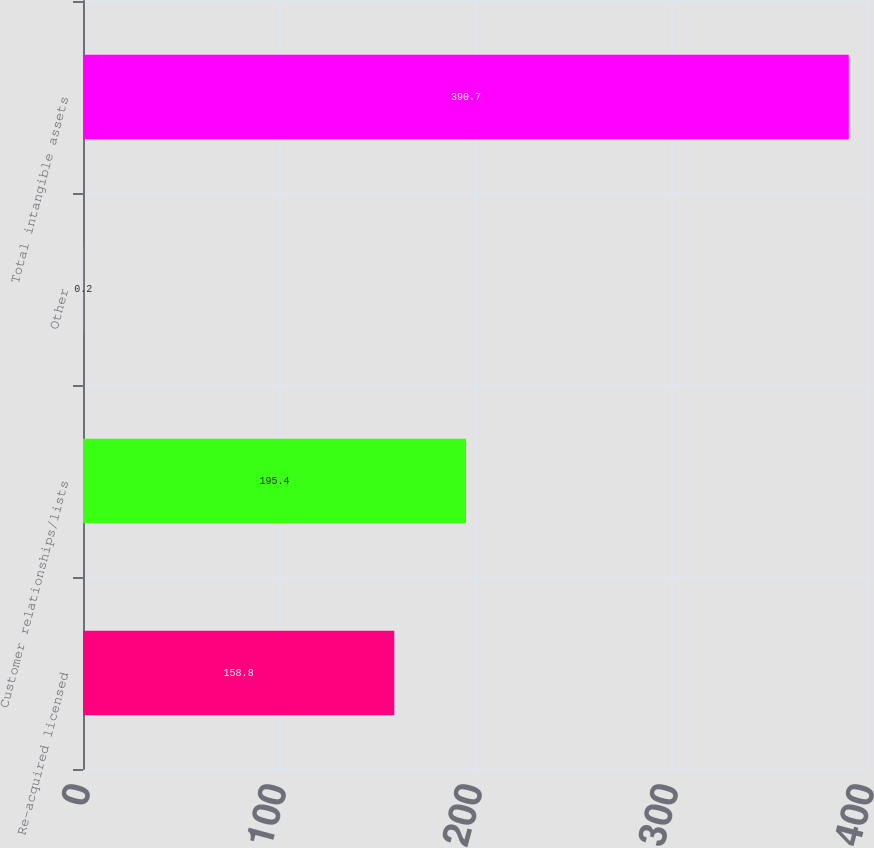Convert chart to OTSL. <chart><loc_0><loc_0><loc_500><loc_500><bar_chart><fcel>Re-acquired licensed<fcel>Customer relationships/lists<fcel>Other<fcel>Total intangible assets<nl><fcel>158.8<fcel>195.4<fcel>0.2<fcel>390.7<nl></chart> 